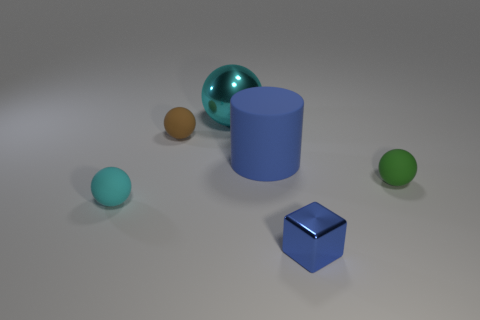What shape is the tiny rubber thing that is right of the blue thing in front of the matte cylinder?
Provide a succinct answer. Sphere. There is a cyan matte thing; does it have the same size as the shiny ball left of the blue shiny cube?
Provide a succinct answer. No. There is a cyan ball that is in front of the small matte ball behind the rubber sphere that is on the right side of the large cyan metal thing; how big is it?
Keep it short and to the point. Small. What number of objects are cyan objects behind the cylinder or cyan shiny objects?
Keep it short and to the point. 1. There is a tiny rubber sphere that is on the right side of the blue shiny thing; how many blue cylinders are in front of it?
Provide a succinct answer. 0. Are there more cyan objects that are on the left side of the small brown matte ball than big red matte cylinders?
Offer a very short reply. Yes. There is a object that is in front of the green matte ball and to the left of the blue cube; what size is it?
Provide a short and direct response. Small. What shape is the object that is to the right of the big shiny ball and to the left of the tiny blue thing?
Keep it short and to the point. Cylinder. There is a thing in front of the cyan thing that is in front of the brown object; is there a thing on the left side of it?
Make the answer very short. Yes. What number of things are either tiny things that are behind the tiny blue metal cube or small rubber objects that are in front of the tiny green matte ball?
Provide a succinct answer. 3. 